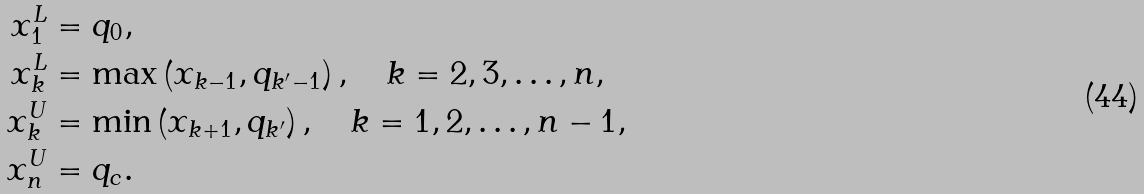Convert formula to latex. <formula><loc_0><loc_0><loc_500><loc_500>x _ { 1 } ^ { L } & = q _ { 0 } , \\ x _ { k } ^ { L } & = \max \left ( x _ { k - 1 } , q _ { k ^ { \prime } - 1 } \right ) , \quad k = 2 , 3 , \dots , n , \\ x _ { k } ^ { U } & = \min \left ( x _ { k + 1 } , q _ { k ^ { \prime } } \right ) , \quad k = 1 , 2 , \dots , n - 1 , \\ x _ { n } ^ { U } & = q _ { c } .</formula> 